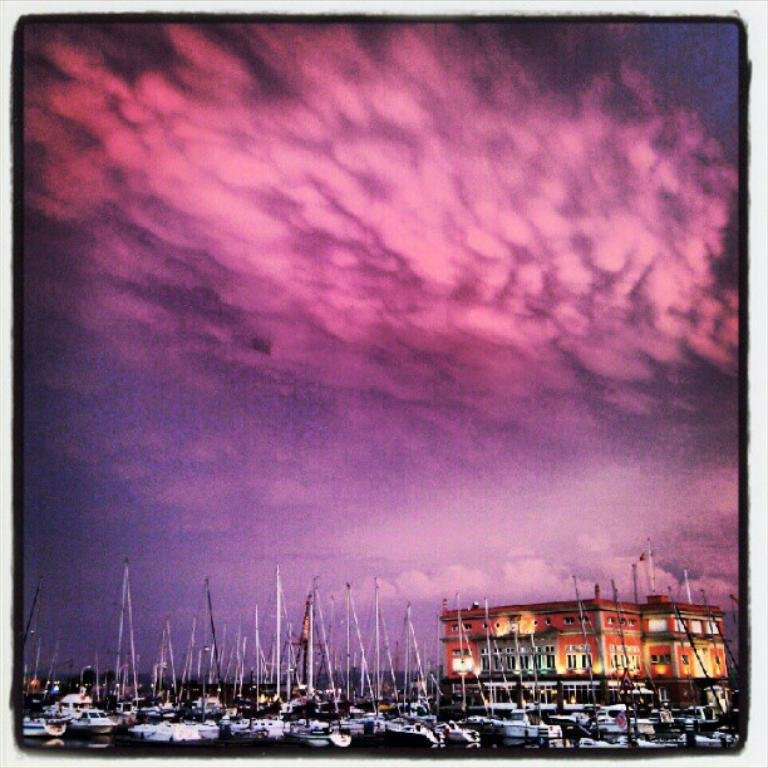What type of editing has been done to the image? The image is edited, but the specific type of editing is not mentioned in the facts. What can be seen on the water in the image? There are boats on the water in the image. What type of structure is present in the image? There is a building in the image. What is visible in the background of the image? The sky is visible in the background of the image. Where is the beggar sitting in the image? There is no beggar present in the image. How many beds are visible in the image? There are no beds visible in the image. 